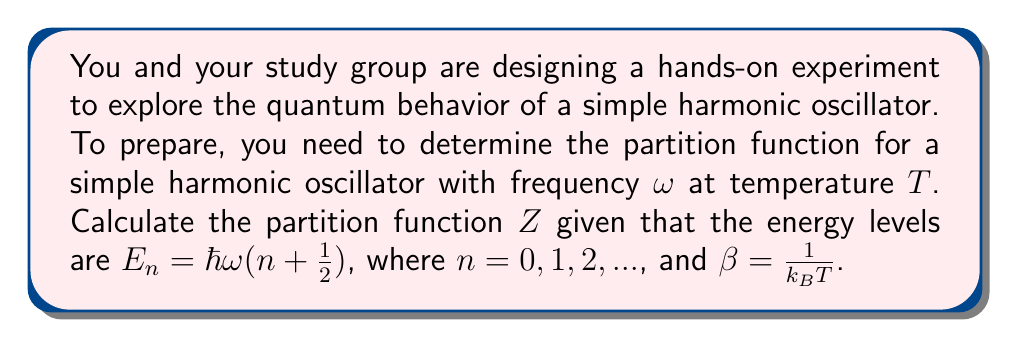Help me with this question. 1) The partition function $Z$ is defined as the sum over all possible states:
   $$Z = \sum_{n=0}^{\infty} e^{-\beta E_n}$$

2) Substitute the energy levels:
   $$Z = \sum_{n=0}^{\infty} e^{-\beta \hbar\omega(n + \frac{1}{2})}$$

3) Factor out the ground state energy:
   $$Z = e^{-\beta \hbar\omega/2} \sum_{n=0}^{\infty} e^{-\beta \hbar\omega n}$$

4) Recognize this as a geometric series with $r = e^{-\beta \hbar\omega}$:
   $$Z = e^{-\beta \hbar\omega/2} \sum_{n=0}^{\infty} (e^{-\beta \hbar\omega})^n$$

5) Use the formula for the sum of an infinite geometric series ($\sum_{n=0}^{\infty} r^n = \frac{1}{1-r}$ for $|r| < 1$):
   $$Z = e^{-\beta \hbar\omega/2} \frac{1}{1 - e^{-\beta \hbar\omega}}$$

6) Simplify by finding a common denominator:
   $$Z = \frac{e^{-\beta \hbar\omega/2}}{1 - e^{-\beta \hbar\omega}} = \frac{e^{\beta \hbar\omega/2}}{e^{\beta \hbar\omega} - 1}$$

This is the partition function for a simple harmonic oscillator.
Answer: $Z = \frac{e^{\beta \hbar\omega/2}}{e^{\beta \hbar\omega} - 1}$ 